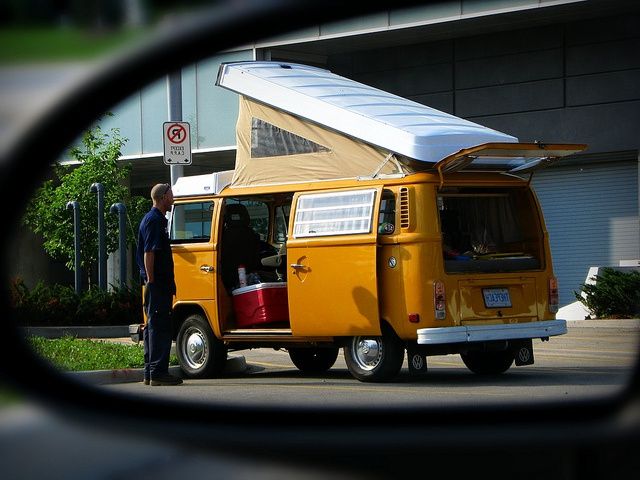Describe the objects in this image and their specific colors. I can see truck in black, white, maroon, and orange tones and people in black, navy, maroon, and gray tones in this image. 